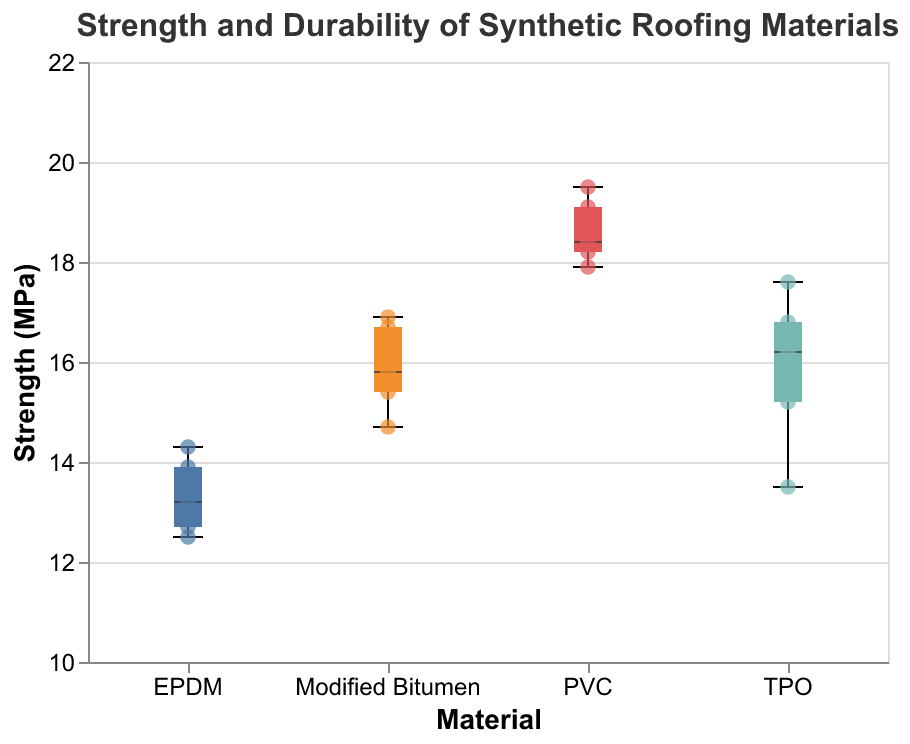What is the range of strength values for TPO? The range is determined by subtracting the minimum value from the maximum value. For TPO, the strength values range from 13.5 MPa to 17.6 MPa. Therefore, 17.6 - 13.5 = 4.1 MPa.
Answer: 4.1 MPa Which material has the highest median strength? The median is represented by the middle line of the box in a box plot. PVC has the highest median strength as the median line is the highest among all the materials.
Answer: PVC What is the interquartile range (IQR) for the durability of PVC? IQR is calculated by subtracting the first quartile (Q1) from the third quartile (Q3). For PVC, Q3 is 25 years, and Q1 is 23 years. Therefore, 25 - 23 = 2 years.
Answer: 2 years Which material shows the most variation in strength? Variation in a box plot is depicted by the length of the whiskers. EPDM has the longest whiskers, indicating the most variation in strength values.
Answer: EPDM How does the median strength of Modified Bitumen compare to TPO? The median strength is indicated by the middle line in the box plot. Modified Bitumen's median strength is lower than TPO's median strength.
Answer: Lower Which materials have outliers in their strength values? Outliers are shown as individual points outside the whiskers in a box plot. No materials in this dataset have strength outliers based on the provided plot.
Answer: None What is the maximum strength recorded for PVC? The maximum strength is represented by the top of the upper whisker in the box plot. For PVC, the maximum strength recorded is 19.5 MPa.
Answer: 19.5 MPa How many materials have a median strength above 16 MPa? By looking at the median lines across all box plots, PVC and Modified Bitumen have median strengths above 16 MPa. There are two such materials.
Answer: 2 What is the overall highest durability value among all materials? The highest durability value is indicated by the top point of the whiskers across all box plots. PVC has the maximum durability value at 25 years.
Answer: 25 years Which material has the smallest range in durability? The range is smallest for EPDM, where the difference between the highest (16 years) and lowest (14 years) durability values is 2 years.
Answer: EPDM 